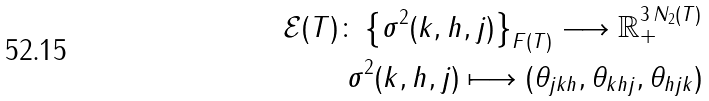<formula> <loc_0><loc_0><loc_500><loc_500>\mathcal { E } ( T ) \colon \left \{ \sigma ^ { 2 } ( k , h , j ) \right \} _ { F ( T ) } \longrightarrow \mathbb { R } _ { + } ^ { 3 \, N _ { 2 } ( T ) } \\ \sigma ^ { 2 } ( k , h , j ) \longmapsto ( \theta _ { j k h } , \theta _ { k h j } , \theta _ { h j k } )</formula> 